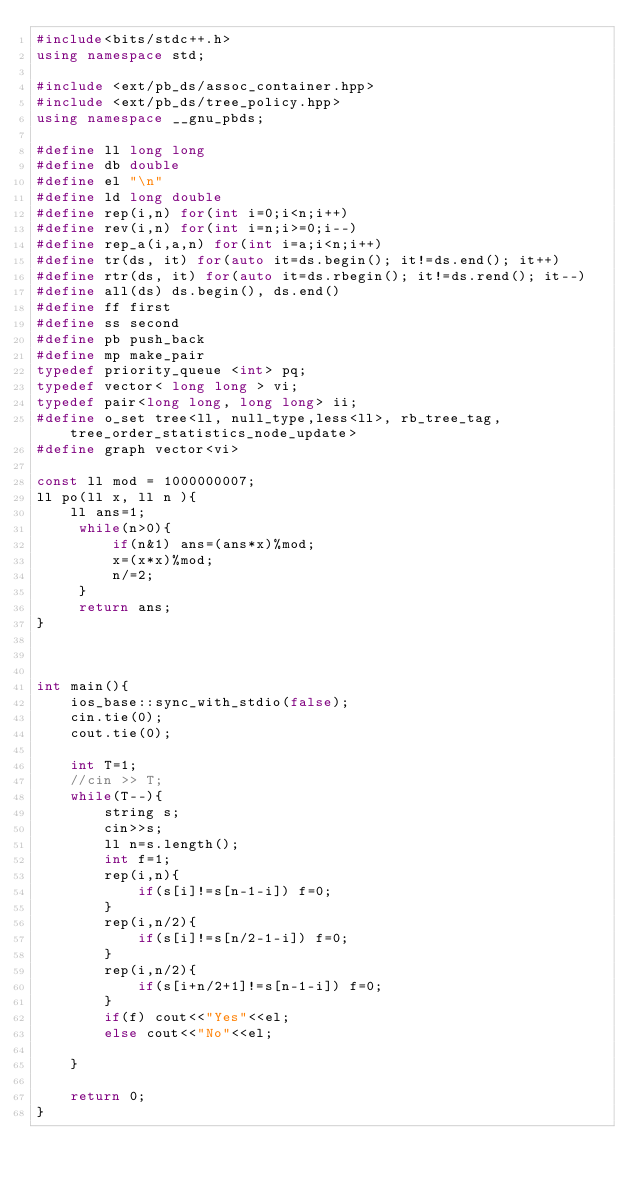Convert code to text. <code><loc_0><loc_0><loc_500><loc_500><_C++_>#include<bits/stdc++.h>
using namespace std;

#include <ext/pb_ds/assoc_container.hpp> 
#include <ext/pb_ds/tree_policy.hpp> 
using namespace __gnu_pbds; 

#define ll long long
#define db double
#define el "\n"
#define ld long double
#define rep(i,n) for(int i=0;i<n;i++)
#define rev(i,n) for(int i=n;i>=0;i--)
#define rep_a(i,a,n) for(int i=a;i<n;i++)
#define tr(ds, it) for(auto it=ds.begin(); it!=ds.end(); it++)
#define rtr(ds, it) for(auto it=ds.rbegin(); it!=ds.rend(); it--)
#define all(ds) ds.begin(), ds.end()
#define ff first
#define ss second
#define pb push_back
#define mp make_pair
typedef priority_queue <int> pq;
typedef vector< long long > vi;
typedef pair<long long, long long> ii;
#define o_set tree<ll, null_type,less<ll>, rb_tree_tag,tree_order_statistics_node_update> 
#define graph vector<vi>

const ll mod = 1000000007;
ll po(ll x, ll n ){ 
    ll ans=1;
     while(n>0){
         if(n&1) ans=(ans*x)%mod;
         x=(x*x)%mod;
         n/=2;
     }
     return ans;
}



int main(){
    ios_base::sync_with_stdio(false);
    cin.tie(0);
    cout.tie(0);
  
    int T=1;
    //cin >> T;
    while(T--){
        string s;
        cin>>s;
        ll n=s.length();
        int f=1;
        rep(i,n){
            if(s[i]!=s[n-1-i]) f=0;
        }
        rep(i,n/2){
            if(s[i]!=s[n/2-1-i]) f=0;
        }
        rep(i,n/2){
            if(s[i+n/2+1]!=s[n-1-i]) f=0;
        }
        if(f) cout<<"Yes"<<el;
        else cout<<"No"<<el;

    }

    return 0;
}</code> 